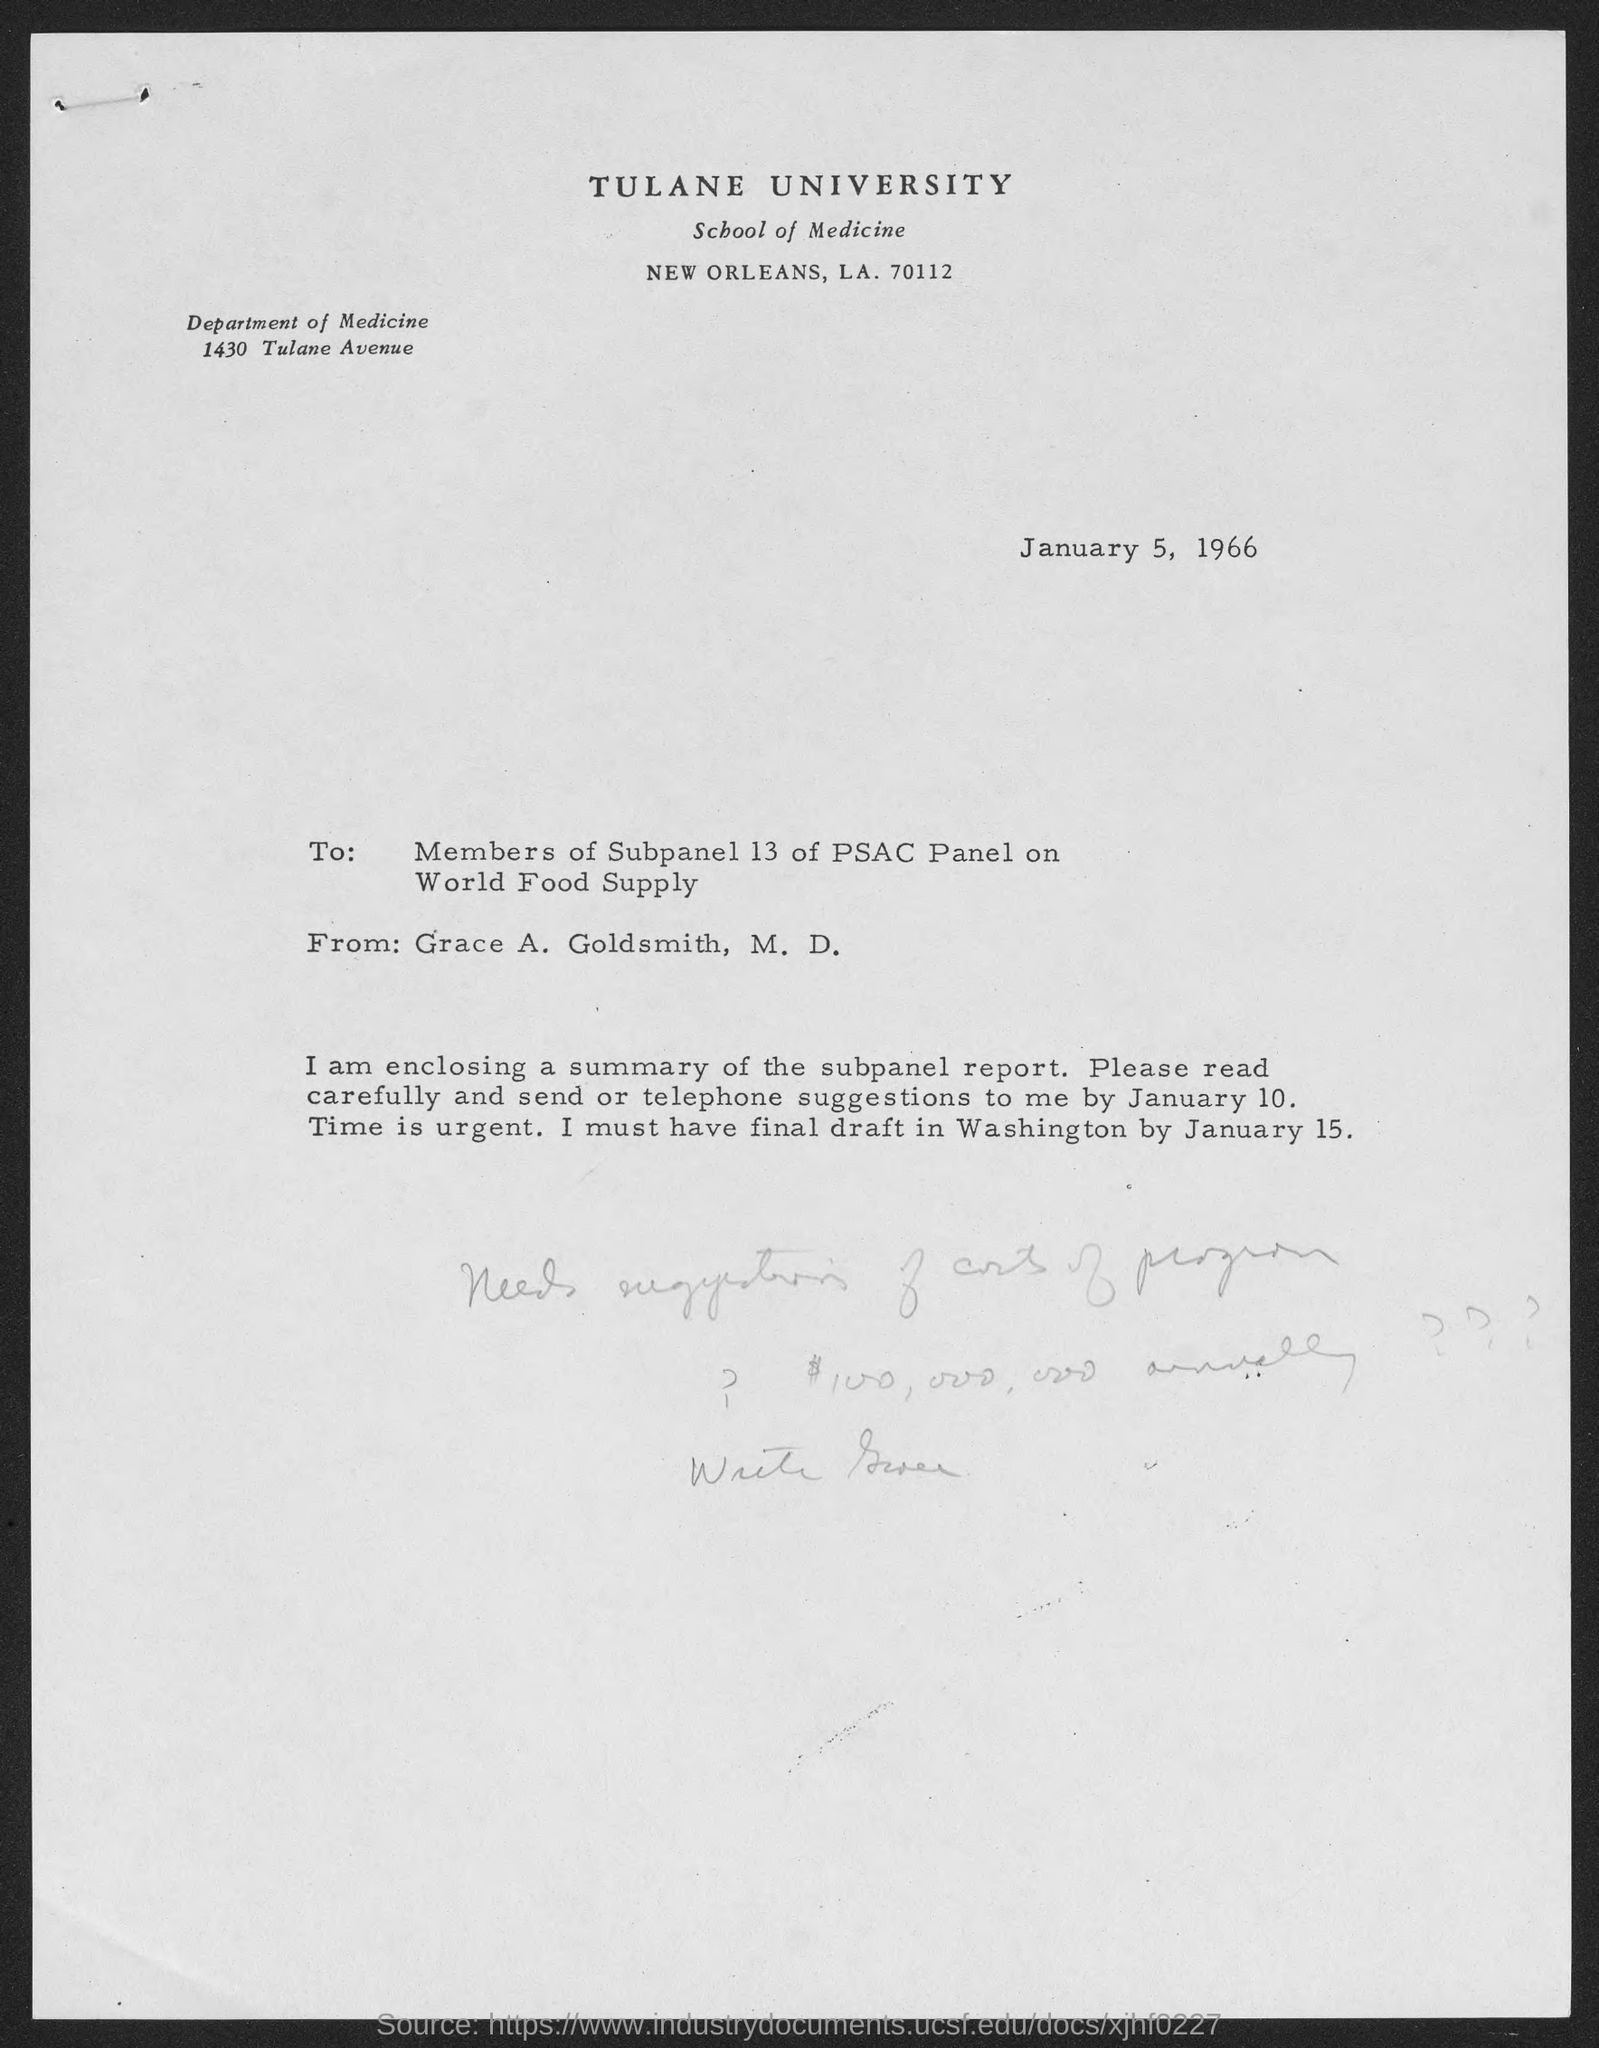Specify some key components in this picture. The memorandum was dated January 5, 1966. Tulane University is located in the county of New Orleans. The address of the Department of Medicine is located at 1430 Tulane Avenue. 